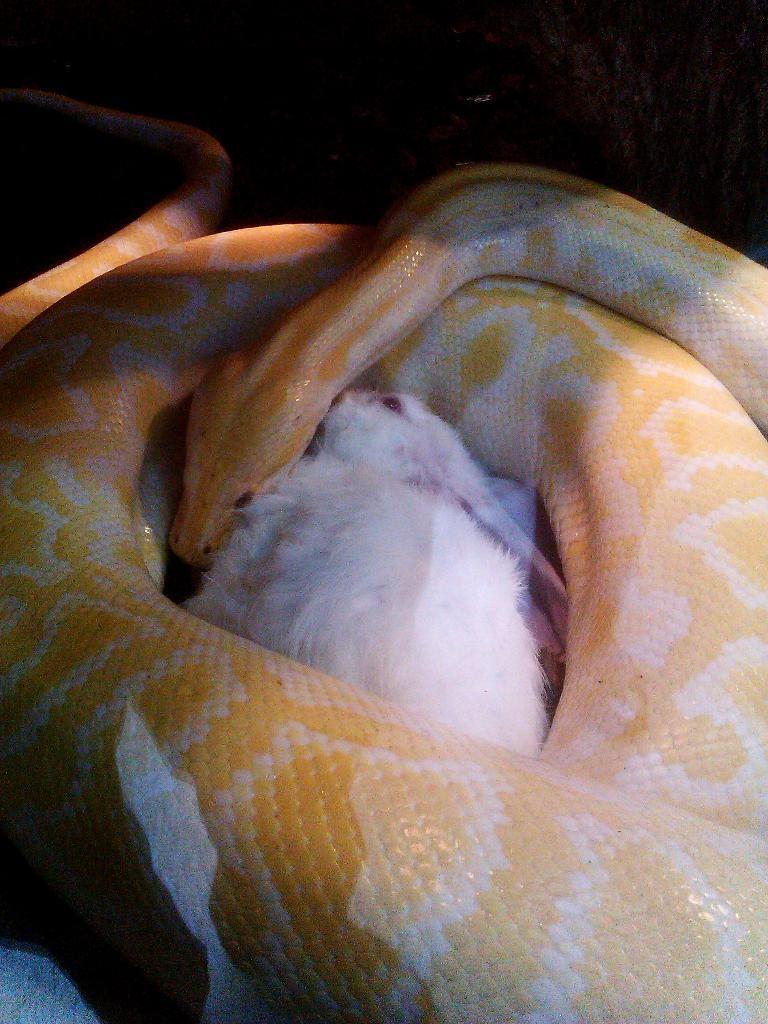Please provide a concise description of this image. In this image we can see a snake and a rabbit. 